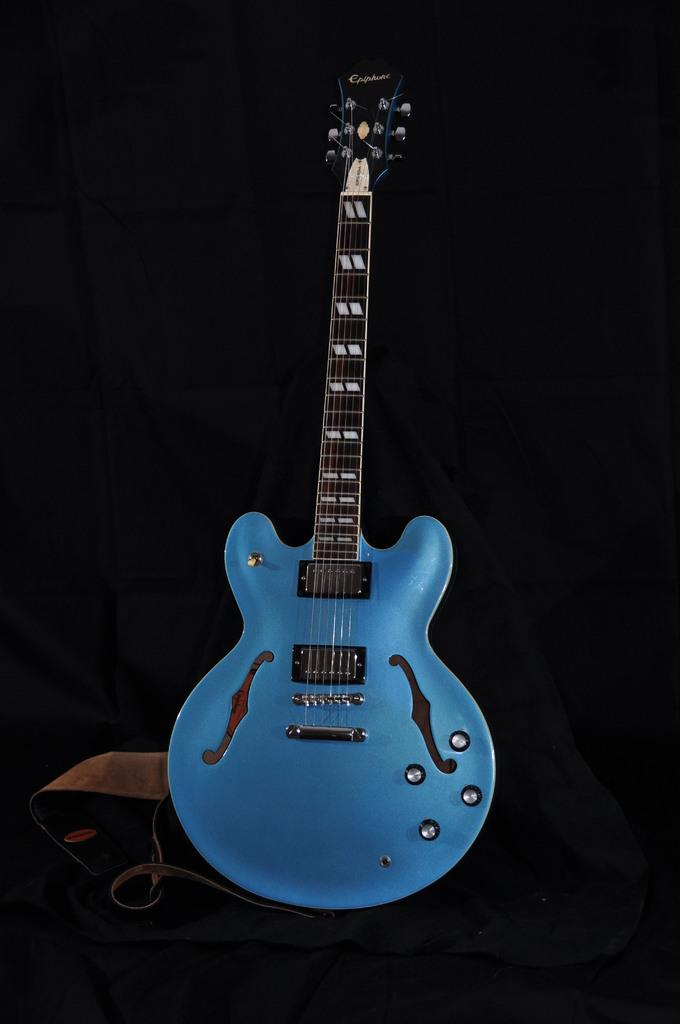What musical instrument is visible in the image? There is a guitar in the image. What is located on the left side of the image? There is a cable and a note-like object on the left side of the image. What is the color of the background in the image? The background of the image is dark. What type of wren can be seen perched on the guitar in the image? There is no wren present in the image; it only features a guitar, a cable, and a note-like object. What is the size of the guitar in the image? The size of the guitar cannot be determined from the image alone, as there is no reference for scale. 